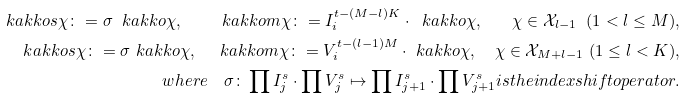Convert formula to latex. <formula><loc_0><loc_0><loc_500><loc_500>\ k a k k o { s \chi } \colon = \sigma \ k a k k o { \chi } , \quad \ k a k k o { m \chi } \colon = I _ { i } ^ { t - ( M - l ) K } \cdot \ k a k k o { \chi } , \quad \chi \in \mathcal { X } _ { l - 1 } \ ( 1 < l \leq M ) , \\ \ k a k k o { s \chi } \colon = \sigma \ k a k k o { \chi } , \quad \ k a k k o { m \chi } \colon = V _ { i } ^ { t - ( l - 1 ) M } \cdot \ k a k k o { \chi } , \quad \chi \in \mathcal { X } _ { M + l - 1 } \ ( 1 \leq l < K ) , \\ w h e r e \quad \sigma \colon \prod { I _ { j } ^ { s } } \cdot \prod { V _ { j } ^ { s } } \mapsto \prod { I _ { j + 1 } ^ { s } } \cdot \prod { V _ { j + 1 } ^ { s } } i s t h e i n d e x s h i f t o p e r a t o r .</formula> 